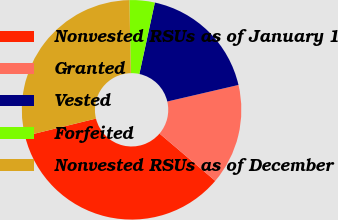Convert chart. <chart><loc_0><loc_0><loc_500><loc_500><pie_chart><fcel>Nonvested RSUs as of January 1<fcel>Granted<fcel>Vested<fcel>Forfeited<fcel>Nonvested RSUs as of December<nl><fcel>34.96%<fcel>14.84%<fcel>17.96%<fcel>3.72%<fcel>28.52%<nl></chart> 